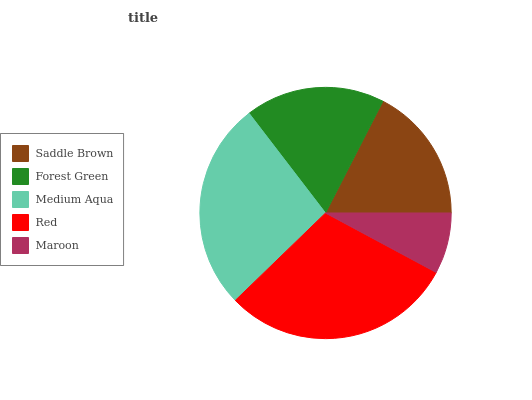Is Maroon the minimum?
Answer yes or no. Yes. Is Red the maximum?
Answer yes or no. Yes. Is Forest Green the minimum?
Answer yes or no. No. Is Forest Green the maximum?
Answer yes or no. No. Is Forest Green greater than Saddle Brown?
Answer yes or no. Yes. Is Saddle Brown less than Forest Green?
Answer yes or no. Yes. Is Saddle Brown greater than Forest Green?
Answer yes or no. No. Is Forest Green less than Saddle Brown?
Answer yes or no. No. Is Forest Green the high median?
Answer yes or no. Yes. Is Forest Green the low median?
Answer yes or no. Yes. Is Maroon the high median?
Answer yes or no. No. Is Saddle Brown the low median?
Answer yes or no. No. 